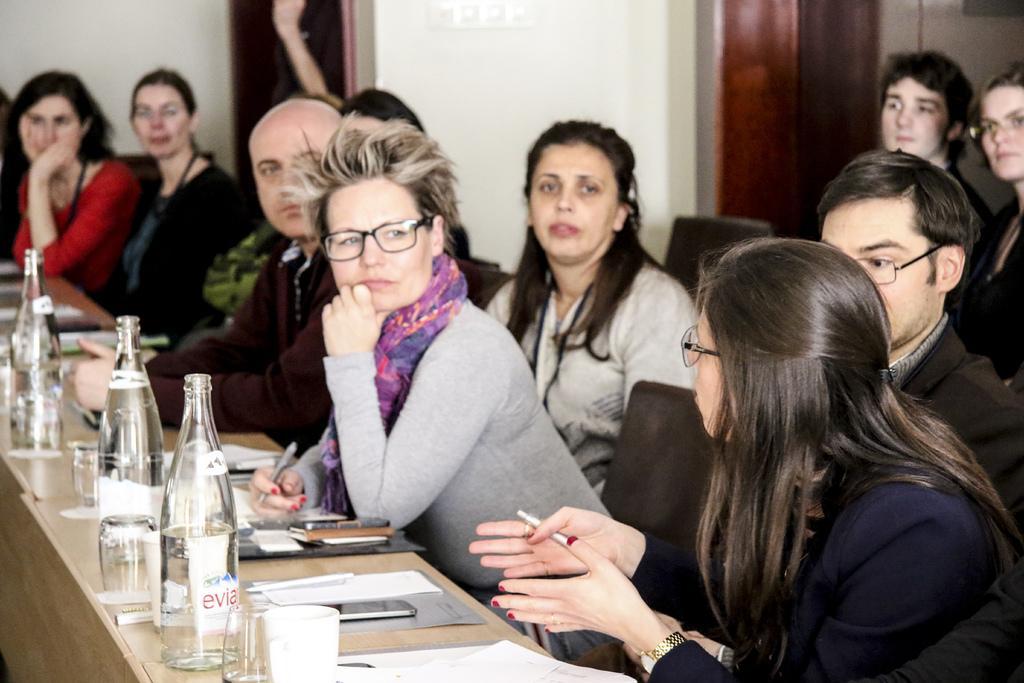Please provide a concise description of this image. In this picture I can see few people are sitting in the chair and I can see few bottles, glasses and few files and papers and a mobile on the tables and I can see couple of women holding pens in their hands and looks like couple of them are standing in the back and I can see a photo frame on the wall. 